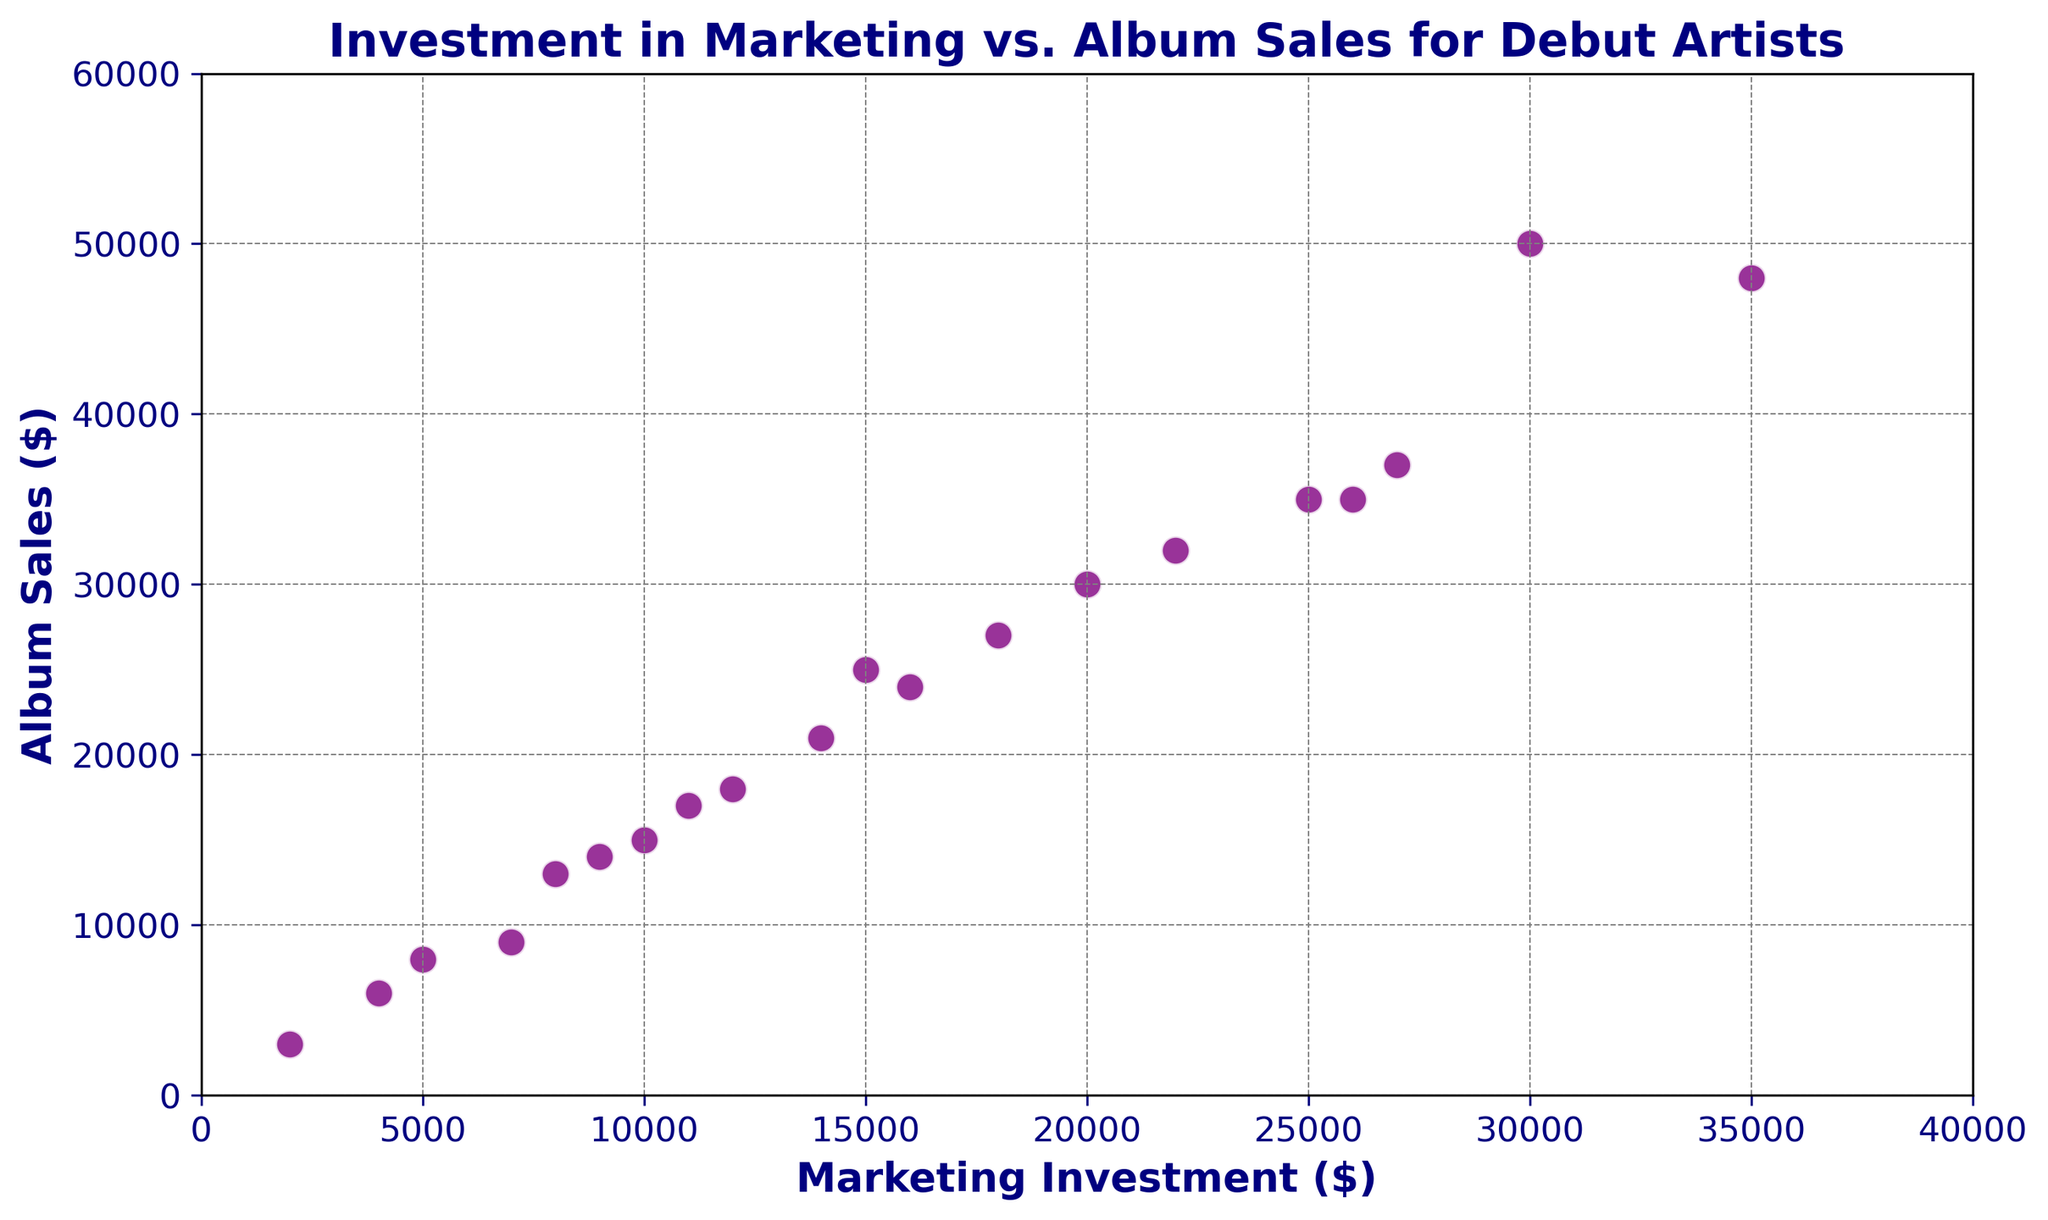What is the highest value of album sales in the figure? The maximum point on the y-axis represents the highest album sales. By observing the data points, the highest value is 50000 located near an investment of 30000.
Answer: 50000 Is there a direct relationship between marketing investment and album sales? Most data points in the figure show an upward trend, indicating that higher marketing investments generally correlate with higher album sales.
Answer: Yes What's the range of marketing investments in the figure? The x-axis runs from 0 to 40000. Observing the data points, the minimum investment is 2000, and the maximum is 35000. Therefore, the range is 35000 - 2000.
Answer: 33000 Which data point indicates the lowest album sales, and what's the corresponding marketing investment? The lowest point on the y-axis represents the smallest album sales. This is 3000, and the corresponding marketing investment can be read vertically, which is 2000.
Answer: 2000, 3000 How many data points have album sales above 30000? By visually counting, the data points above the y-axis value of 30000 are 8 in total.
Answer: 8 Are there any outliers in the data? Outliers would be points significantly distant from the general trend. Observing the data, all points seem to adhere closely to the positive trend with no outliers.
Answer: No What is the average album sales for investments between 10000 and 20000? Points with investments of 10000, 15000, 12000, 18000, 16000, and 14000 have corresponding album sales of 15000, 25000, 18000, 27000, 24000, and 21000. Sum of sales is 15000 + 25000 + 18000 + 27000 + 24000 + 21000 = 130000. Divide by 6 (number of points).
Answer: 21667 How does the album sales for a 35000 investment compare to a 30000 investment? The album sales for a 35000 investment is around 48000, while for a 30000 investment it is 50000. By comparison, 30000 investment yields higher sales by 2000.
Answer: Higher by 2000 Which data point, in terms of investment, lies near the center of the x-axis range? The x-axis ranges from 0 to 40000, so the center is at 20000. The nearest investment value is exactly 20000, with corresponding album sales of 30000.
Answer: 20000 What's the approximate increase in album sales from the lowest investment to the highest? The lowest investment is 2000 with album sales of 3000. The highest investment is 35000 with album sales of 48000. The difference in sales is 48000 - 3000.
Answer: 45000 